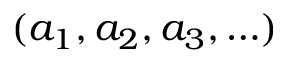Convert formula to latex. <formula><loc_0><loc_0><loc_500><loc_500>( a _ { 1 } , a _ { 2 } , a _ { 3 } , \dots )</formula> 